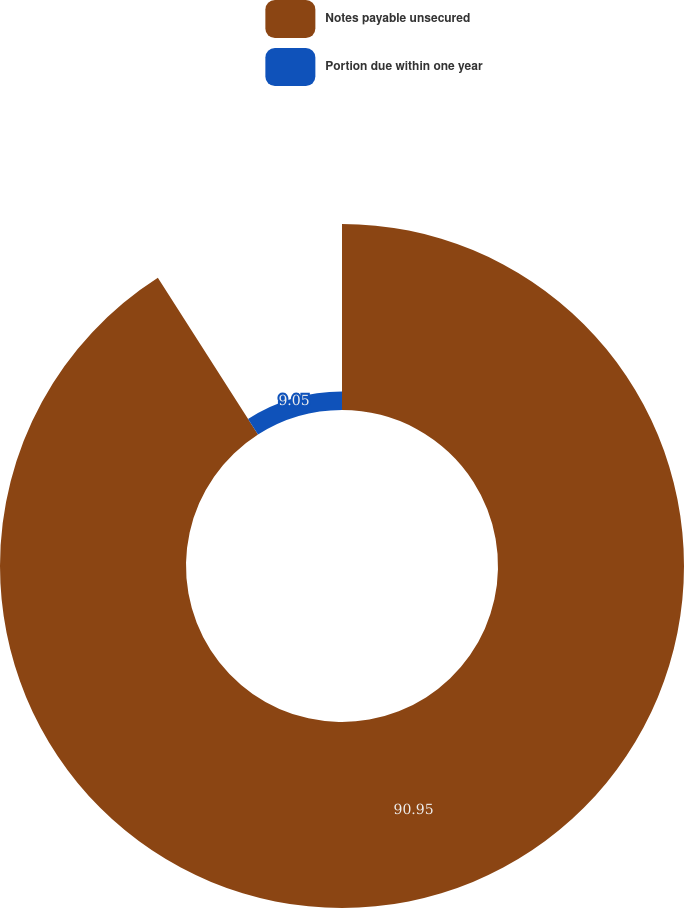Convert chart. <chart><loc_0><loc_0><loc_500><loc_500><pie_chart><fcel>Notes payable unsecured<fcel>Portion due within one year<nl><fcel>90.95%<fcel>9.05%<nl></chart> 